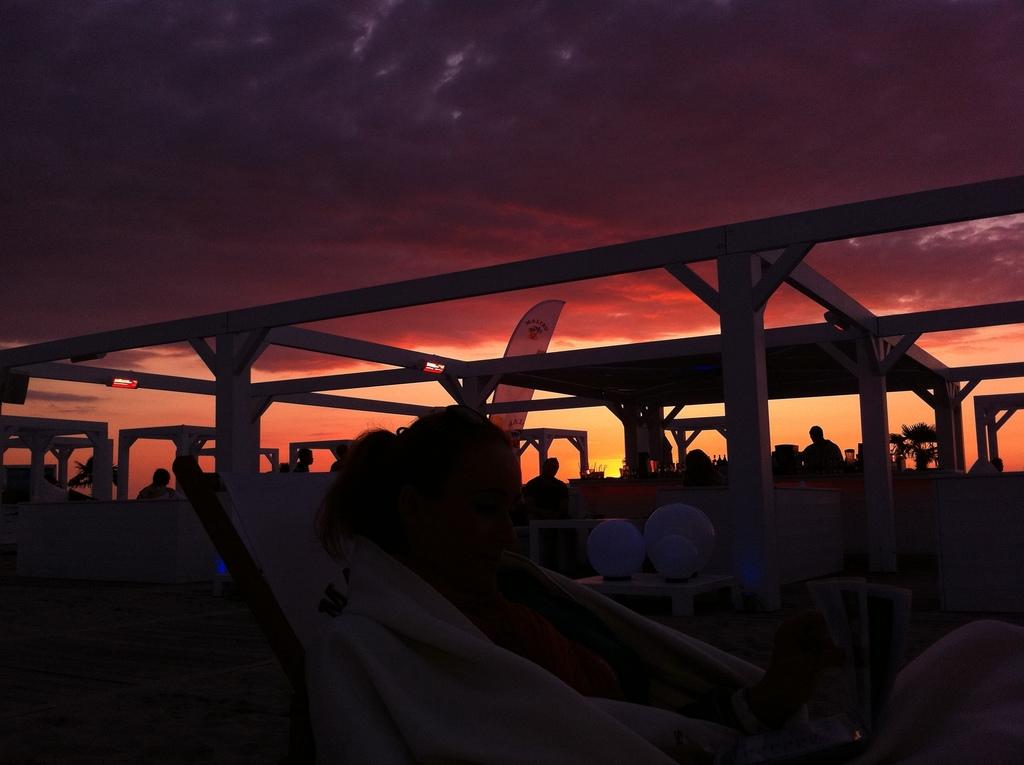What is the lady in the image doing? The lady is sitting on a chair in the image. What is the lady wearing? The lady is wearing a towel in the image. What can be seen in the background of the image? There are pillars in the background of the image. How many people are present in the image? There are many people present in the image. What objects can be seen on the tables in the image? There are tables with lamps in the image. What part of the natural environment is visible in the image? The sky is visible in the background of the image. What type of eyes can be seen on the carriage in the image? There is no carriage present in the image, so there are no eyes to be seen. 